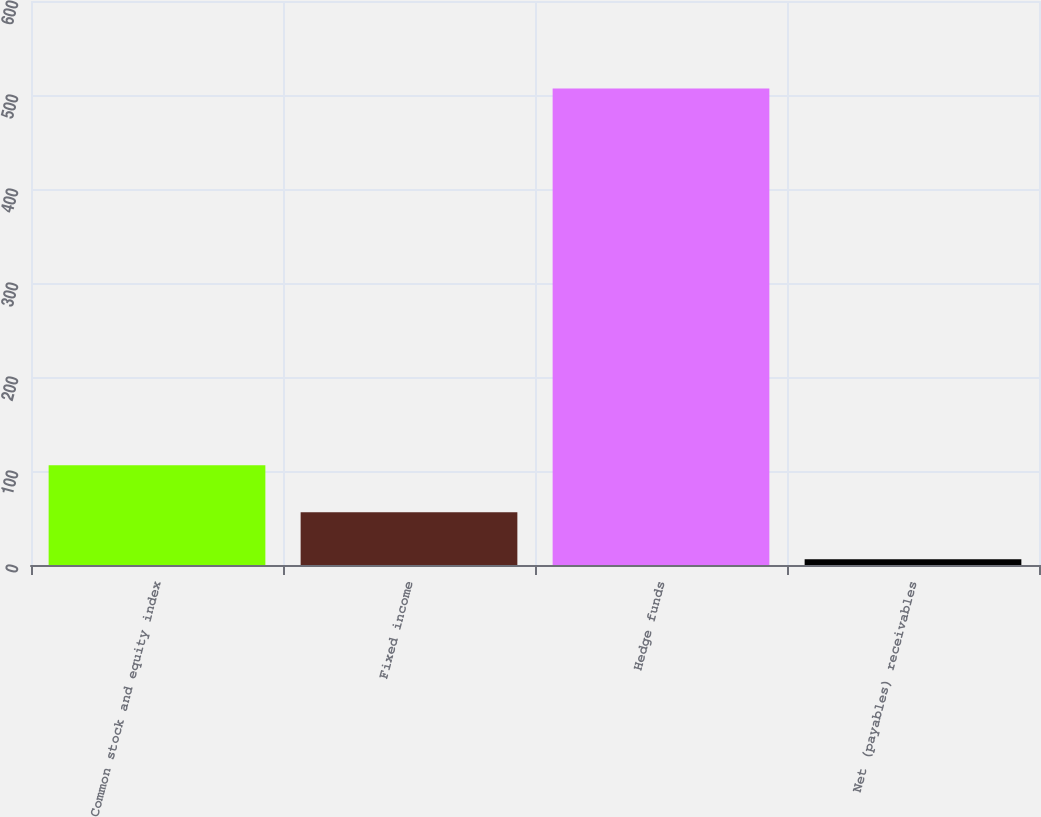Convert chart. <chart><loc_0><loc_0><loc_500><loc_500><bar_chart><fcel>Common stock and equity index<fcel>Fixed income<fcel>Hedge funds<fcel>Net (payables) receivables<nl><fcel>106.2<fcel>56.1<fcel>507<fcel>6<nl></chart> 